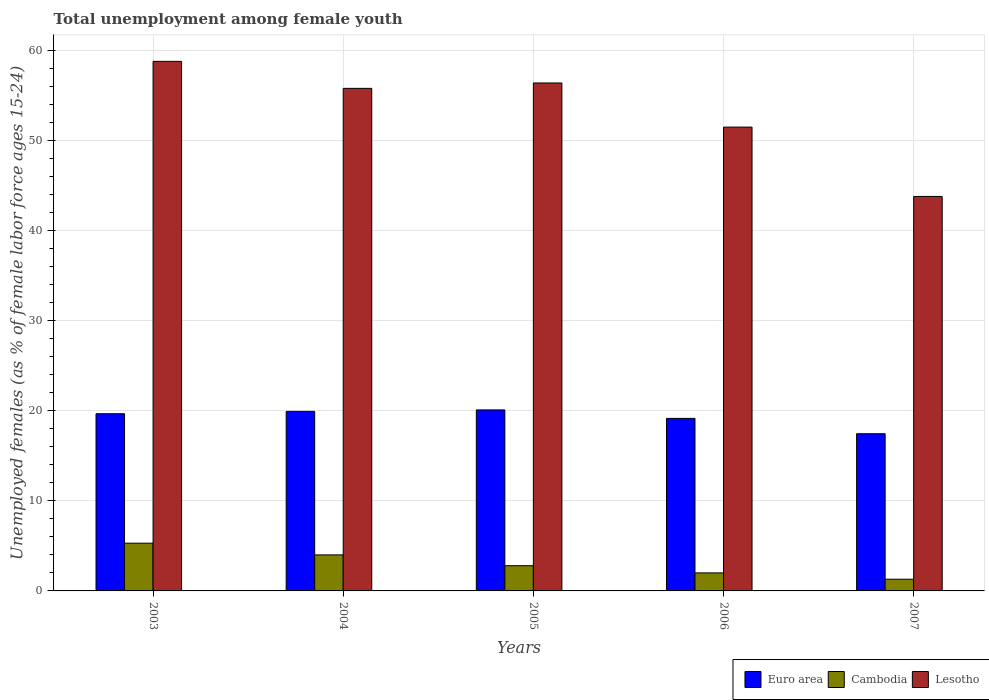Are the number of bars per tick equal to the number of legend labels?
Provide a succinct answer. Yes. Are the number of bars on each tick of the X-axis equal?
Your response must be concise. Yes. How many bars are there on the 1st tick from the right?
Give a very brief answer. 3. What is the label of the 2nd group of bars from the left?
Your answer should be very brief. 2004. What is the percentage of unemployed females in in Cambodia in 2006?
Your response must be concise. 2. Across all years, what is the maximum percentage of unemployed females in in Euro area?
Offer a very short reply. 20.1. Across all years, what is the minimum percentage of unemployed females in in Cambodia?
Your answer should be very brief. 1.3. In which year was the percentage of unemployed females in in Euro area maximum?
Ensure brevity in your answer.  2005. What is the total percentage of unemployed females in in Lesotho in the graph?
Make the answer very short. 266.3. What is the difference between the percentage of unemployed females in in Lesotho in 2005 and that in 2006?
Provide a short and direct response. 4.9. What is the difference between the percentage of unemployed females in in Euro area in 2007 and the percentage of unemployed females in in Cambodia in 2006?
Ensure brevity in your answer.  15.45. What is the average percentage of unemployed females in in Cambodia per year?
Offer a very short reply. 3.08. In the year 2005, what is the difference between the percentage of unemployed females in in Cambodia and percentage of unemployed females in in Lesotho?
Make the answer very short. -53.6. What is the ratio of the percentage of unemployed females in in Euro area in 2004 to that in 2005?
Make the answer very short. 0.99. Is the percentage of unemployed females in in Cambodia in 2003 less than that in 2004?
Ensure brevity in your answer.  No. Is the difference between the percentage of unemployed females in in Cambodia in 2003 and 2007 greater than the difference between the percentage of unemployed females in in Lesotho in 2003 and 2007?
Your response must be concise. No. What is the difference between the highest and the second highest percentage of unemployed females in in Lesotho?
Give a very brief answer. 2.4. What is the difference between the highest and the lowest percentage of unemployed females in in Euro area?
Keep it short and to the point. 2.64. Is the sum of the percentage of unemployed females in in Lesotho in 2003 and 2005 greater than the maximum percentage of unemployed females in in Cambodia across all years?
Make the answer very short. Yes. What does the 1st bar from the left in 2005 represents?
Your response must be concise. Euro area. What does the 1st bar from the right in 2005 represents?
Ensure brevity in your answer.  Lesotho. Is it the case that in every year, the sum of the percentage of unemployed females in in Lesotho and percentage of unemployed females in in Euro area is greater than the percentage of unemployed females in in Cambodia?
Your response must be concise. Yes. Are all the bars in the graph horizontal?
Keep it short and to the point. No. Does the graph contain any zero values?
Your answer should be compact. No. Where does the legend appear in the graph?
Your answer should be compact. Bottom right. How many legend labels are there?
Ensure brevity in your answer.  3. What is the title of the graph?
Keep it short and to the point. Total unemployment among female youth. What is the label or title of the X-axis?
Your answer should be compact. Years. What is the label or title of the Y-axis?
Ensure brevity in your answer.  Unemployed females (as % of female labor force ages 15-24). What is the Unemployed females (as % of female labor force ages 15-24) in Euro area in 2003?
Offer a very short reply. 19.67. What is the Unemployed females (as % of female labor force ages 15-24) of Cambodia in 2003?
Offer a terse response. 5.3. What is the Unemployed females (as % of female labor force ages 15-24) in Lesotho in 2003?
Your answer should be compact. 58.8. What is the Unemployed females (as % of female labor force ages 15-24) of Euro area in 2004?
Make the answer very short. 19.94. What is the Unemployed females (as % of female labor force ages 15-24) in Cambodia in 2004?
Ensure brevity in your answer.  4. What is the Unemployed females (as % of female labor force ages 15-24) of Lesotho in 2004?
Keep it short and to the point. 55.8. What is the Unemployed females (as % of female labor force ages 15-24) in Euro area in 2005?
Give a very brief answer. 20.1. What is the Unemployed females (as % of female labor force ages 15-24) of Cambodia in 2005?
Make the answer very short. 2.8. What is the Unemployed females (as % of female labor force ages 15-24) in Lesotho in 2005?
Your response must be concise. 56.4. What is the Unemployed females (as % of female labor force ages 15-24) of Euro area in 2006?
Your response must be concise. 19.16. What is the Unemployed females (as % of female labor force ages 15-24) in Cambodia in 2006?
Give a very brief answer. 2. What is the Unemployed females (as % of female labor force ages 15-24) in Lesotho in 2006?
Make the answer very short. 51.5. What is the Unemployed females (as % of female labor force ages 15-24) in Euro area in 2007?
Offer a terse response. 17.45. What is the Unemployed females (as % of female labor force ages 15-24) of Cambodia in 2007?
Make the answer very short. 1.3. What is the Unemployed females (as % of female labor force ages 15-24) of Lesotho in 2007?
Make the answer very short. 43.8. Across all years, what is the maximum Unemployed females (as % of female labor force ages 15-24) of Euro area?
Ensure brevity in your answer.  20.1. Across all years, what is the maximum Unemployed females (as % of female labor force ages 15-24) of Cambodia?
Your answer should be compact. 5.3. Across all years, what is the maximum Unemployed females (as % of female labor force ages 15-24) of Lesotho?
Provide a short and direct response. 58.8. Across all years, what is the minimum Unemployed females (as % of female labor force ages 15-24) of Euro area?
Your response must be concise. 17.45. Across all years, what is the minimum Unemployed females (as % of female labor force ages 15-24) of Cambodia?
Your answer should be compact. 1.3. Across all years, what is the minimum Unemployed females (as % of female labor force ages 15-24) in Lesotho?
Make the answer very short. 43.8. What is the total Unemployed females (as % of female labor force ages 15-24) in Euro area in the graph?
Provide a short and direct response. 96.32. What is the total Unemployed females (as % of female labor force ages 15-24) in Lesotho in the graph?
Ensure brevity in your answer.  266.3. What is the difference between the Unemployed females (as % of female labor force ages 15-24) in Euro area in 2003 and that in 2004?
Offer a very short reply. -0.26. What is the difference between the Unemployed females (as % of female labor force ages 15-24) of Cambodia in 2003 and that in 2004?
Keep it short and to the point. 1.3. What is the difference between the Unemployed females (as % of female labor force ages 15-24) of Euro area in 2003 and that in 2005?
Provide a short and direct response. -0.42. What is the difference between the Unemployed females (as % of female labor force ages 15-24) in Cambodia in 2003 and that in 2005?
Give a very brief answer. 2.5. What is the difference between the Unemployed females (as % of female labor force ages 15-24) in Euro area in 2003 and that in 2006?
Ensure brevity in your answer.  0.52. What is the difference between the Unemployed females (as % of female labor force ages 15-24) in Cambodia in 2003 and that in 2006?
Provide a succinct answer. 3.3. What is the difference between the Unemployed females (as % of female labor force ages 15-24) in Lesotho in 2003 and that in 2006?
Keep it short and to the point. 7.3. What is the difference between the Unemployed females (as % of female labor force ages 15-24) in Euro area in 2003 and that in 2007?
Provide a succinct answer. 2.22. What is the difference between the Unemployed females (as % of female labor force ages 15-24) of Lesotho in 2003 and that in 2007?
Your answer should be very brief. 15. What is the difference between the Unemployed females (as % of female labor force ages 15-24) in Euro area in 2004 and that in 2005?
Give a very brief answer. -0.16. What is the difference between the Unemployed females (as % of female labor force ages 15-24) in Lesotho in 2004 and that in 2005?
Make the answer very short. -0.6. What is the difference between the Unemployed females (as % of female labor force ages 15-24) in Euro area in 2004 and that in 2006?
Offer a terse response. 0.78. What is the difference between the Unemployed females (as % of female labor force ages 15-24) in Lesotho in 2004 and that in 2006?
Your answer should be very brief. 4.3. What is the difference between the Unemployed females (as % of female labor force ages 15-24) in Euro area in 2004 and that in 2007?
Your answer should be very brief. 2.48. What is the difference between the Unemployed females (as % of female labor force ages 15-24) of Euro area in 2005 and that in 2006?
Provide a succinct answer. 0.94. What is the difference between the Unemployed females (as % of female labor force ages 15-24) in Lesotho in 2005 and that in 2006?
Make the answer very short. 4.9. What is the difference between the Unemployed females (as % of female labor force ages 15-24) of Euro area in 2005 and that in 2007?
Provide a short and direct response. 2.64. What is the difference between the Unemployed females (as % of female labor force ages 15-24) of Cambodia in 2005 and that in 2007?
Provide a succinct answer. 1.5. What is the difference between the Unemployed females (as % of female labor force ages 15-24) of Lesotho in 2005 and that in 2007?
Keep it short and to the point. 12.6. What is the difference between the Unemployed females (as % of female labor force ages 15-24) of Euro area in 2006 and that in 2007?
Offer a very short reply. 1.7. What is the difference between the Unemployed females (as % of female labor force ages 15-24) of Euro area in 2003 and the Unemployed females (as % of female labor force ages 15-24) of Cambodia in 2004?
Offer a terse response. 15.67. What is the difference between the Unemployed females (as % of female labor force ages 15-24) in Euro area in 2003 and the Unemployed females (as % of female labor force ages 15-24) in Lesotho in 2004?
Your answer should be very brief. -36.13. What is the difference between the Unemployed females (as % of female labor force ages 15-24) of Cambodia in 2003 and the Unemployed females (as % of female labor force ages 15-24) of Lesotho in 2004?
Provide a short and direct response. -50.5. What is the difference between the Unemployed females (as % of female labor force ages 15-24) in Euro area in 2003 and the Unemployed females (as % of female labor force ages 15-24) in Cambodia in 2005?
Your answer should be very brief. 16.87. What is the difference between the Unemployed females (as % of female labor force ages 15-24) in Euro area in 2003 and the Unemployed females (as % of female labor force ages 15-24) in Lesotho in 2005?
Provide a short and direct response. -36.73. What is the difference between the Unemployed females (as % of female labor force ages 15-24) of Cambodia in 2003 and the Unemployed females (as % of female labor force ages 15-24) of Lesotho in 2005?
Ensure brevity in your answer.  -51.1. What is the difference between the Unemployed females (as % of female labor force ages 15-24) in Euro area in 2003 and the Unemployed females (as % of female labor force ages 15-24) in Cambodia in 2006?
Ensure brevity in your answer.  17.67. What is the difference between the Unemployed females (as % of female labor force ages 15-24) in Euro area in 2003 and the Unemployed females (as % of female labor force ages 15-24) in Lesotho in 2006?
Your response must be concise. -31.83. What is the difference between the Unemployed females (as % of female labor force ages 15-24) in Cambodia in 2003 and the Unemployed females (as % of female labor force ages 15-24) in Lesotho in 2006?
Your answer should be very brief. -46.2. What is the difference between the Unemployed females (as % of female labor force ages 15-24) in Euro area in 2003 and the Unemployed females (as % of female labor force ages 15-24) in Cambodia in 2007?
Offer a terse response. 18.37. What is the difference between the Unemployed females (as % of female labor force ages 15-24) in Euro area in 2003 and the Unemployed females (as % of female labor force ages 15-24) in Lesotho in 2007?
Your response must be concise. -24.13. What is the difference between the Unemployed females (as % of female labor force ages 15-24) in Cambodia in 2003 and the Unemployed females (as % of female labor force ages 15-24) in Lesotho in 2007?
Give a very brief answer. -38.5. What is the difference between the Unemployed females (as % of female labor force ages 15-24) of Euro area in 2004 and the Unemployed females (as % of female labor force ages 15-24) of Cambodia in 2005?
Ensure brevity in your answer.  17.14. What is the difference between the Unemployed females (as % of female labor force ages 15-24) in Euro area in 2004 and the Unemployed females (as % of female labor force ages 15-24) in Lesotho in 2005?
Ensure brevity in your answer.  -36.46. What is the difference between the Unemployed females (as % of female labor force ages 15-24) of Cambodia in 2004 and the Unemployed females (as % of female labor force ages 15-24) of Lesotho in 2005?
Your answer should be very brief. -52.4. What is the difference between the Unemployed females (as % of female labor force ages 15-24) of Euro area in 2004 and the Unemployed females (as % of female labor force ages 15-24) of Cambodia in 2006?
Provide a succinct answer. 17.94. What is the difference between the Unemployed females (as % of female labor force ages 15-24) in Euro area in 2004 and the Unemployed females (as % of female labor force ages 15-24) in Lesotho in 2006?
Provide a short and direct response. -31.56. What is the difference between the Unemployed females (as % of female labor force ages 15-24) of Cambodia in 2004 and the Unemployed females (as % of female labor force ages 15-24) of Lesotho in 2006?
Offer a very short reply. -47.5. What is the difference between the Unemployed females (as % of female labor force ages 15-24) in Euro area in 2004 and the Unemployed females (as % of female labor force ages 15-24) in Cambodia in 2007?
Your answer should be very brief. 18.64. What is the difference between the Unemployed females (as % of female labor force ages 15-24) of Euro area in 2004 and the Unemployed females (as % of female labor force ages 15-24) of Lesotho in 2007?
Your answer should be compact. -23.86. What is the difference between the Unemployed females (as % of female labor force ages 15-24) in Cambodia in 2004 and the Unemployed females (as % of female labor force ages 15-24) in Lesotho in 2007?
Keep it short and to the point. -39.8. What is the difference between the Unemployed females (as % of female labor force ages 15-24) of Euro area in 2005 and the Unemployed females (as % of female labor force ages 15-24) of Cambodia in 2006?
Your response must be concise. 18.1. What is the difference between the Unemployed females (as % of female labor force ages 15-24) in Euro area in 2005 and the Unemployed females (as % of female labor force ages 15-24) in Lesotho in 2006?
Offer a terse response. -31.4. What is the difference between the Unemployed females (as % of female labor force ages 15-24) of Cambodia in 2005 and the Unemployed females (as % of female labor force ages 15-24) of Lesotho in 2006?
Your answer should be very brief. -48.7. What is the difference between the Unemployed females (as % of female labor force ages 15-24) in Euro area in 2005 and the Unemployed females (as % of female labor force ages 15-24) in Cambodia in 2007?
Your response must be concise. 18.8. What is the difference between the Unemployed females (as % of female labor force ages 15-24) of Euro area in 2005 and the Unemployed females (as % of female labor force ages 15-24) of Lesotho in 2007?
Provide a short and direct response. -23.7. What is the difference between the Unemployed females (as % of female labor force ages 15-24) of Cambodia in 2005 and the Unemployed females (as % of female labor force ages 15-24) of Lesotho in 2007?
Give a very brief answer. -41. What is the difference between the Unemployed females (as % of female labor force ages 15-24) of Euro area in 2006 and the Unemployed females (as % of female labor force ages 15-24) of Cambodia in 2007?
Your answer should be very brief. 17.86. What is the difference between the Unemployed females (as % of female labor force ages 15-24) of Euro area in 2006 and the Unemployed females (as % of female labor force ages 15-24) of Lesotho in 2007?
Offer a terse response. -24.64. What is the difference between the Unemployed females (as % of female labor force ages 15-24) of Cambodia in 2006 and the Unemployed females (as % of female labor force ages 15-24) of Lesotho in 2007?
Your answer should be compact. -41.8. What is the average Unemployed females (as % of female labor force ages 15-24) of Euro area per year?
Your response must be concise. 19.26. What is the average Unemployed females (as % of female labor force ages 15-24) in Cambodia per year?
Ensure brevity in your answer.  3.08. What is the average Unemployed females (as % of female labor force ages 15-24) of Lesotho per year?
Your answer should be very brief. 53.26. In the year 2003, what is the difference between the Unemployed females (as % of female labor force ages 15-24) in Euro area and Unemployed females (as % of female labor force ages 15-24) in Cambodia?
Give a very brief answer. 14.37. In the year 2003, what is the difference between the Unemployed females (as % of female labor force ages 15-24) in Euro area and Unemployed females (as % of female labor force ages 15-24) in Lesotho?
Offer a terse response. -39.13. In the year 2003, what is the difference between the Unemployed females (as % of female labor force ages 15-24) in Cambodia and Unemployed females (as % of female labor force ages 15-24) in Lesotho?
Offer a very short reply. -53.5. In the year 2004, what is the difference between the Unemployed females (as % of female labor force ages 15-24) in Euro area and Unemployed females (as % of female labor force ages 15-24) in Cambodia?
Your answer should be compact. 15.94. In the year 2004, what is the difference between the Unemployed females (as % of female labor force ages 15-24) of Euro area and Unemployed females (as % of female labor force ages 15-24) of Lesotho?
Make the answer very short. -35.86. In the year 2004, what is the difference between the Unemployed females (as % of female labor force ages 15-24) in Cambodia and Unemployed females (as % of female labor force ages 15-24) in Lesotho?
Give a very brief answer. -51.8. In the year 2005, what is the difference between the Unemployed females (as % of female labor force ages 15-24) in Euro area and Unemployed females (as % of female labor force ages 15-24) in Cambodia?
Give a very brief answer. 17.3. In the year 2005, what is the difference between the Unemployed females (as % of female labor force ages 15-24) in Euro area and Unemployed females (as % of female labor force ages 15-24) in Lesotho?
Your answer should be compact. -36.3. In the year 2005, what is the difference between the Unemployed females (as % of female labor force ages 15-24) in Cambodia and Unemployed females (as % of female labor force ages 15-24) in Lesotho?
Your response must be concise. -53.6. In the year 2006, what is the difference between the Unemployed females (as % of female labor force ages 15-24) of Euro area and Unemployed females (as % of female labor force ages 15-24) of Cambodia?
Ensure brevity in your answer.  17.16. In the year 2006, what is the difference between the Unemployed females (as % of female labor force ages 15-24) of Euro area and Unemployed females (as % of female labor force ages 15-24) of Lesotho?
Offer a terse response. -32.34. In the year 2006, what is the difference between the Unemployed females (as % of female labor force ages 15-24) of Cambodia and Unemployed females (as % of female labor force ages 15-24) of Lesotho?
Your response must be concise. -49.5. In the year 2007, what is the difference between the Unemployed females (as % of female labor force ages 15-24) of Euro area and Unemployed females (as % of female labor force ages 15-24) of Cambodia?
Provide a short and direct response. 16.15. In the year 2007, what is the difference between the Unemployed females (as % of female labor force ages 15-24) of Euro area and Unemployed females (as % of female labor force ages 15-24) of Lesotho?
Give a very brief answer. -26.35. In the year 2007, what is the difference between the Unemployed females (as % of female labor force ages 15-24) of Cambodia and Unemployed females (as % of female labor force ages 15-24) of Lesotho?
Your response must be concise. -42.5. What is the ratio of the Unemployed females (as % of female labor force ages 15-24) of Euro area in 2003 to that in 2004?
Your response must be concise. 0.99. What is the ratio of the Unemployed females (as % of female labor force ages 15-24) of Cambodia in 2003 to that in 2004?
Give a very brief answer. 1.32. What is the ratio of the Unemployed females (as % of female labor force ages 15-24) in Lesotho in 2003 to that in 2004?
Your answer should be compact. 1.05. What is the ratio of the Unemployed females (as % of female labor force ages 15-24) in Euro area in 2003 to that in 2005?
Keep it short and to the point. 0.98. What is the ratio of the Unemployed females (as % of female labor force ages 15-24) in Cambodia in 2003 to that in 2005?
Offer a terse response. 1.89. What is the ratio of the Unemployed females (as % of female labor force ages 15-24) of Lesotho in 2003 to that in 2005?
Your response must be concise. 1.04. What is the ratio of the Unemployed females (as % of female labor force ages 15-24) in Euro area in 2003 to that in 2006?
Offer a very short reply. 1.03. What is the ratio of the Unemployed females (as % of female labor force ages 15-24) of Cambodia in 2003 to that in 2006?
Provide a succinct answer. 2.65. What is the ratio of the Unemployed females (as % of female labor force ages 15-24) in Lesotho in 2003 to that in 2006?
Offer a terse response. 1.14. What is the ratio of the Unemployed females (as % of female labor force ages 15-24) in Euro area in 2003 to that in 2007?
Your answer should be very brief. 1.13. What is the ratio of the Unemployed females (as % of female labor force ages 15-24) of Cambodia in 2003 to that in 2007?
Your answer should be very brief. 4.08. What is the ratio of the Unemployed females (as % of female labor force ages 15-24) in Lesotho in 2003 to that in 2007?
Your answer should be compact. 1.34. What is the ratio of the Unemployed females (as % of female labor force ages 15-24) in Euro area in 2004 to that in 2005?
Your response must be concise. 0.99. What is the ratio of the Unemployed females (as % of female labor force ages 15-24) of Cambodia in 2004 to that in 2005?
Provide a succinct answer. 1.43. What is the ratio of the Unemployed females (as % of female labor force ages 15-24) in Lesotho in 2004 to that in 2005?
Offer a terse response. 0.99. What is the ratio of the Unemployed females (as % of female labor force ages 15-24) of Euro area in 2004 to that in 2006?
Offer a terse response. 1.04. What is the ratio of the Unemployed females (as % of female labor force ages 15-24) of Lesotho in 2004 to that in 2006?
Offer a very short reply. 1.08. What is the ratio of the Unemployed females (as % of female labor force ages 15-24) in Euro area in 2004 to that in 2007?
Your response must be concise. 1.14. What is the ratio of the Unemployed females (as % of female labor force ages 15-24) in Cambodia in 2004 to that in 2007?
Offer a very short reply. 3.08. What is the ratio of the Unemployed females (as % of female labor force ages 15-24) in Lesotho in 2004 to that in 2007?
Give a very brief answer. 1.27. What is the ratio of the Unemployed females (as % of female labor force ages 15-24) in Euro area in 2005 to that in 2006?
Offer a terse response. 1.05. What is the ratio of the Unemployed females (as % of female labor force ages 15-24) of Lesotho in 2005 to that in 2006?
Offer a very short reply. 1.1. What is the ratio of the Unemployed females (as % of female labor force ages 15-24) of Euro area in 2005 to that in 2007?
Ensure brevity in your answer.  1.15. What is the ratio of the Unemployed females (as % of female labor force ages 15-24) in Cambodia in 2005 to that in 2007?
Keep it short and to the point. 2.15. What is the ratio of the Unemployed females (as % of female labor force ages 15-24) of Lesotho in 2005 to that in 2007?
Keep it short and to the point. 1.29. What is the ratio of the Unemployed females (as % of female labor force ages 15-24) of Euro area in 2006 to that in 2007?
Provide a succinct answer. 1.1. What is the ratio of the Unemployed females (as % of female labor force ages 15-24) in Cambodia in 2006 to that in 2007?
Make the answer very short. 1.54. What is the ratio of the Unemployed females (as % of female labor force ages 15-24) of Lesotho in 2006 to that in 2007?
Keep it short and to the point. 1.18. What is the difference between the highest and the second highest Unemployed females (as % of female labor force ages 15-24) in Euro area?
Provide a succinct answer. 0.16. What is the difference between the highest and the second highest Unemployed females (as % of female labor force ages 15-24) in Cambodia?
Ensure brevity in your answer.  1.3. What is the difference between the highest and the second highest Unemployed females (as % of female labor force ages 15-24) of Lesotho?
Ensure brevity in your answer.  2.4. What is the difference between the highest and the lowest Unemployed females (as % of female labor force ages 15-24) of Euro area?
Make the answer very short. 2.64. What is the difference between the highest and the lowest Unemployed females (as % of female labor force ages 15-24) of Lesotho?
Give a very brief answer. 15. 